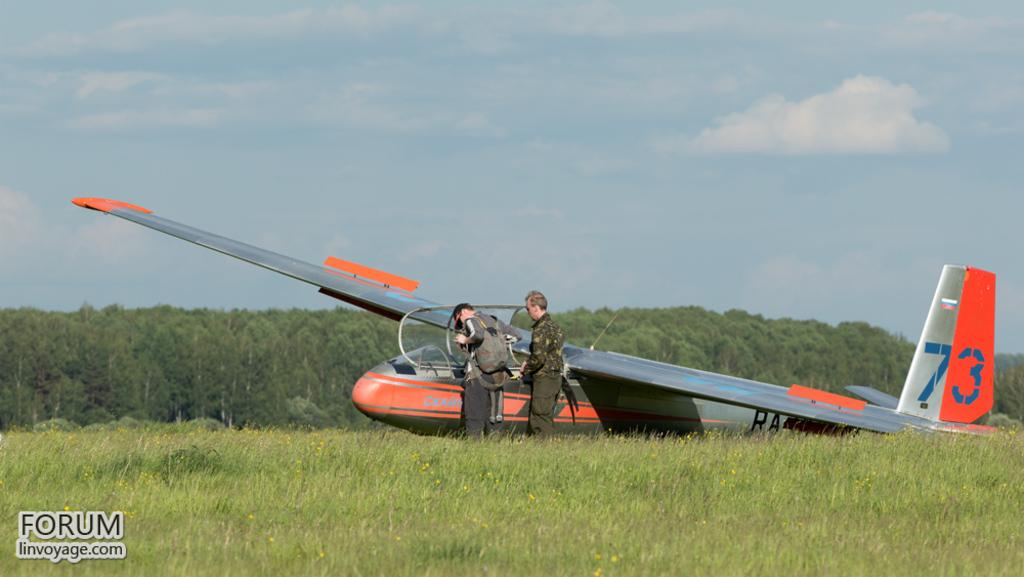<image>
Give a short and clear explanation of the subsequent image. the russian plane with the number 73 has landed in a field 